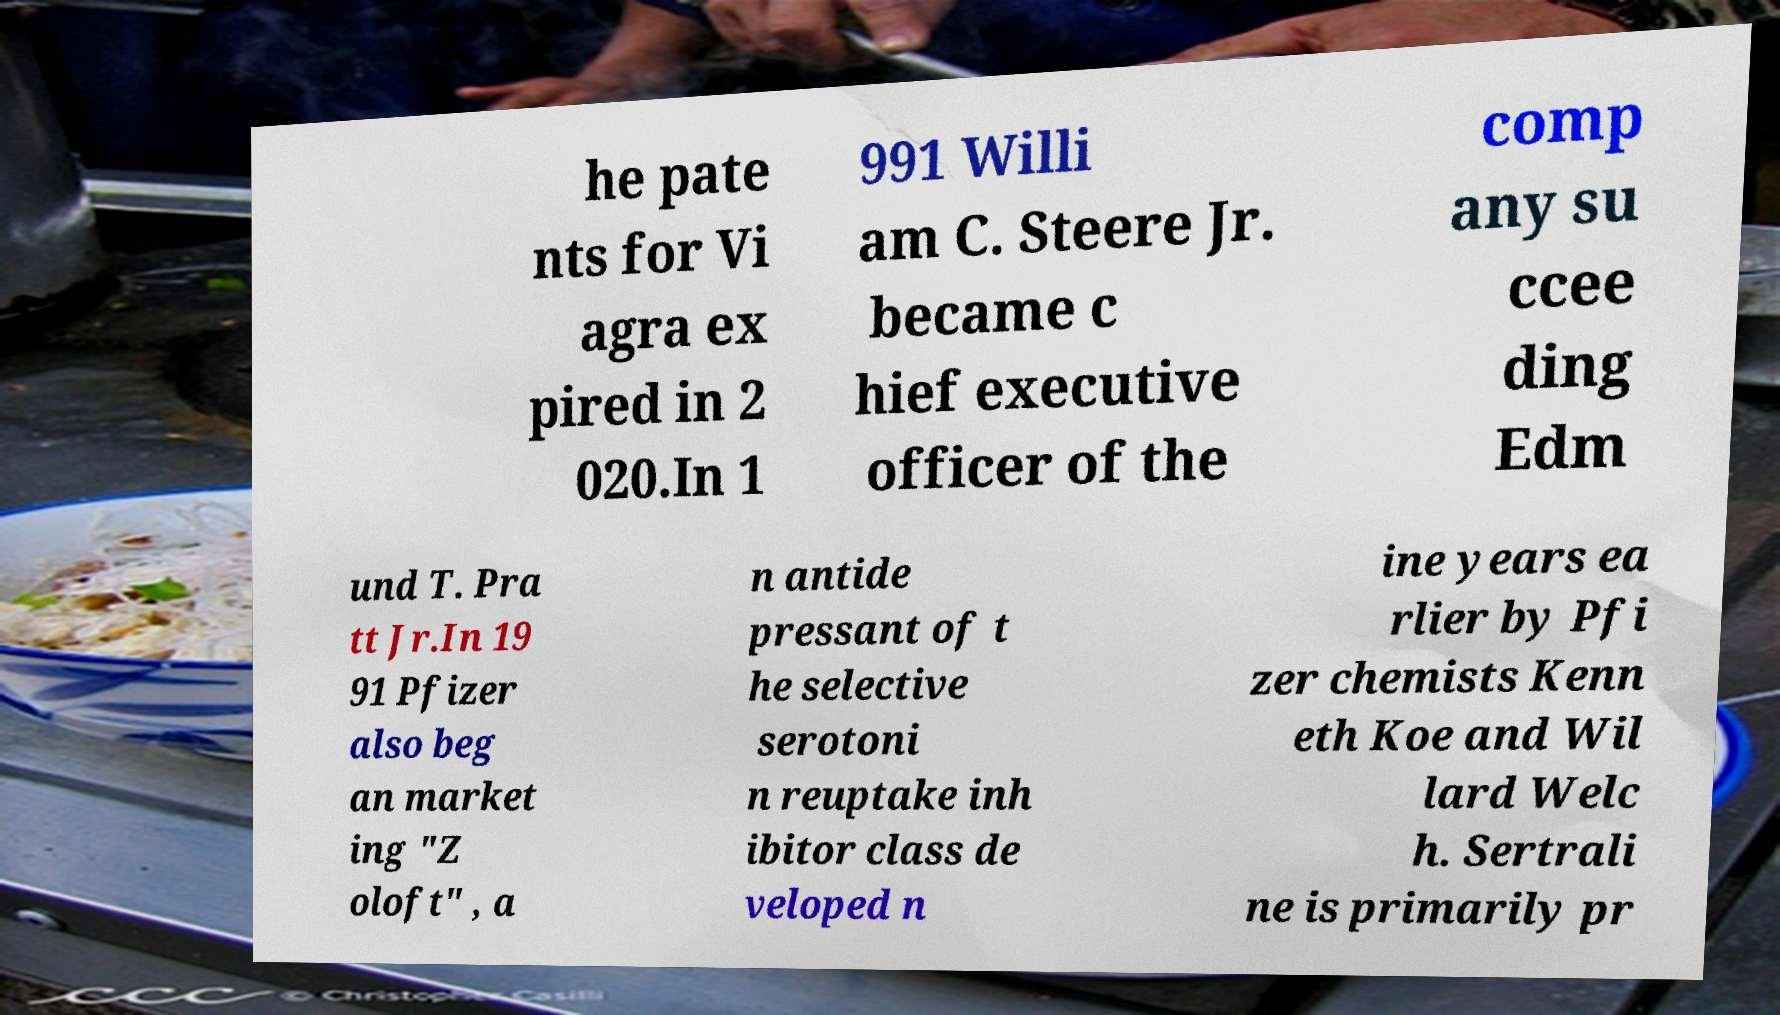What messages or text are displayed in this image? I need them in a readable, typed format. he pate nts for Vi agra ex pired in 2 020.In 1 991 Willi am C. Steere Jr. became c hief executive officer of the comp any su ccee ding Edm und T. Pra tt Jr.In 19 91 Pfizer also beg an market ing "Z oloft" , a n antide pressant of t he selective serotoni n reuptake inh ibitor class de veloped n ine years ea rlier by Pfi zer chemists Kenn eth Koe and Wil lard Welc h. Sertrali ne is primarily pr 